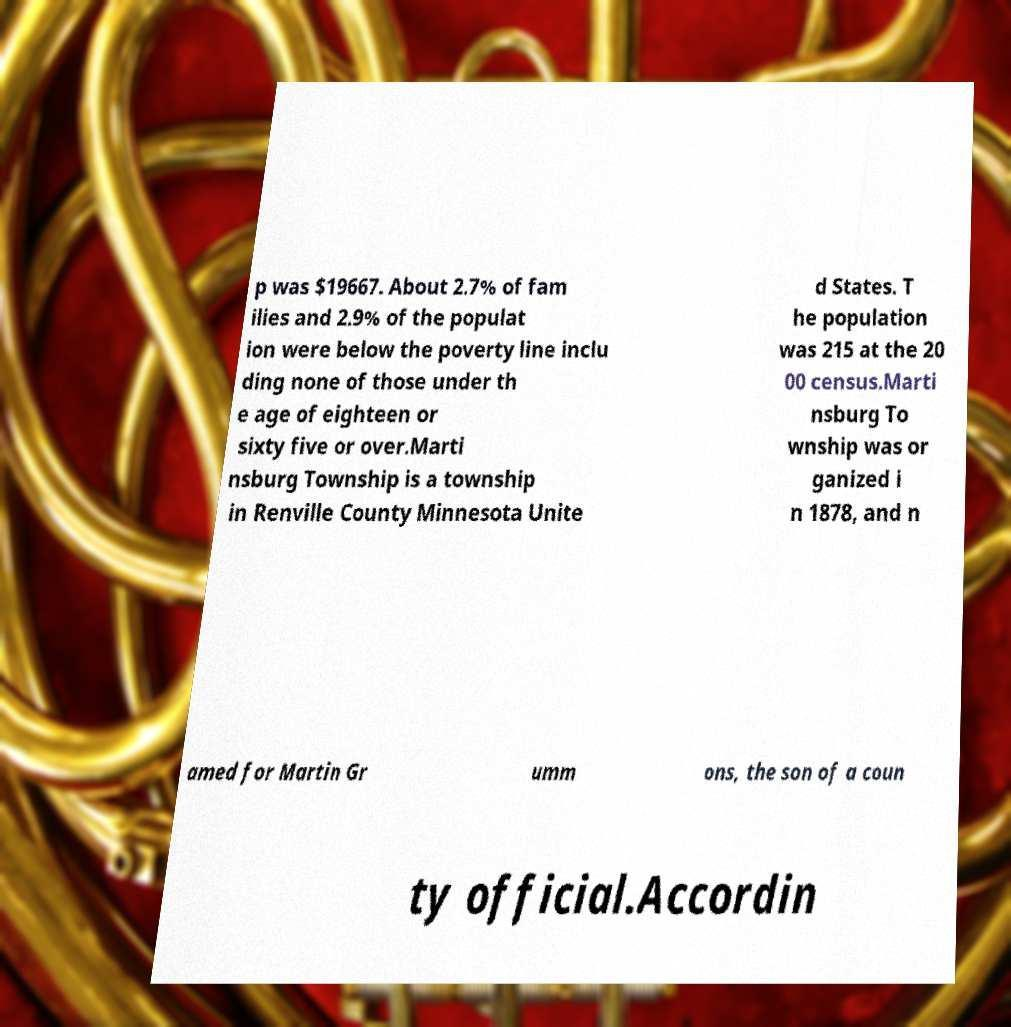I need the written content from this picture converted into text. Can you do that? p was $19667. About 2.7% of fam ilies and 2.9% of the populat ion were below the poverty line inclu ding none of those under th e age of eighteen or sixty five or over.Marti nsburg Township is a township in Renville County Minnesota Unite d States. T he population was 215 at the 20 00 census.Marti nsburg To wnship was or ganized i n 1878, and n amed for Martin Gr umm ons, the son of a coun ty official.Accordin 